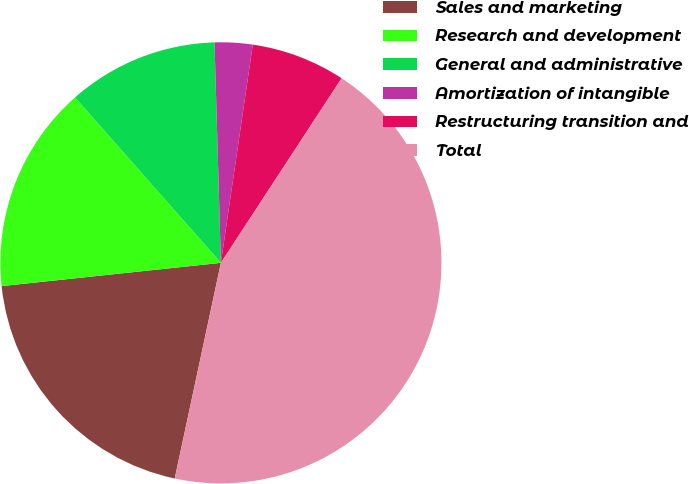Convert chart. <chart><loc_0><loc_0><loc_500><loc_500><pie_chart><fcel>Sales and marketing<fcel>Research and development<fcel>General and administrative<fcel>Amortization of intangible<fcel>Restructuring transition and<fcel>Total<nl><fcel>19.96%<fcel>15.18%<fcel>11.04%<fcel>2.77%<fcel>6.91%<fcel>44.14%<nl></chart> 